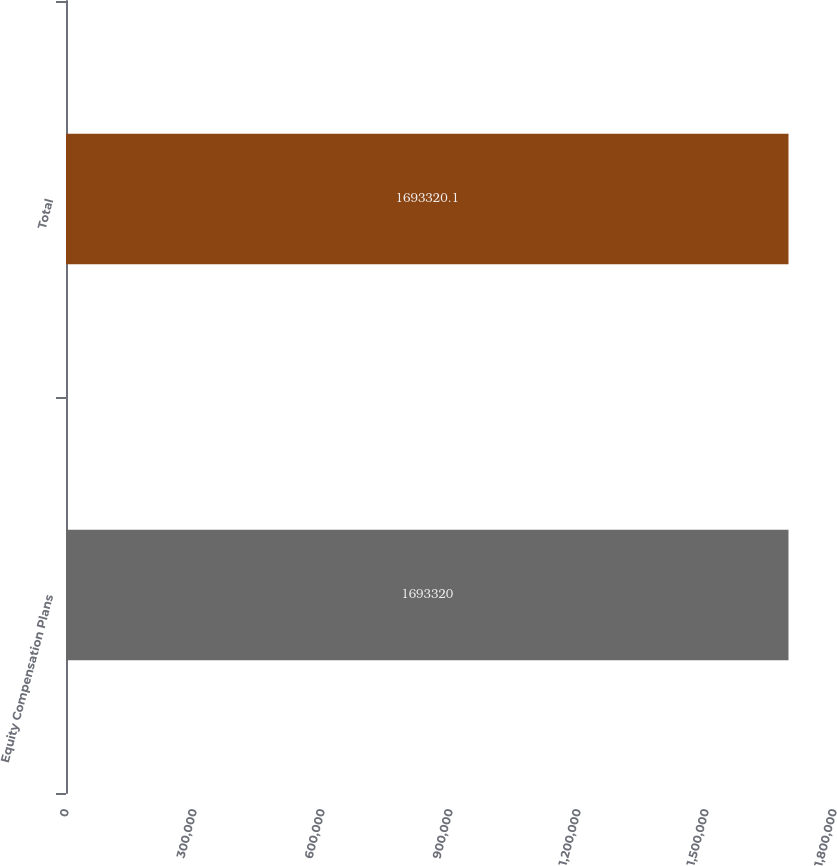Convert chart to OTSL. <chart><loc_0><loc_0><loc_500><loc_500><bar_chart><fcel>Equity Compensation Plans<fcel>Total<nl><fcel>1.69332e+06<fcel>1.69332e+06<nl></chart> 